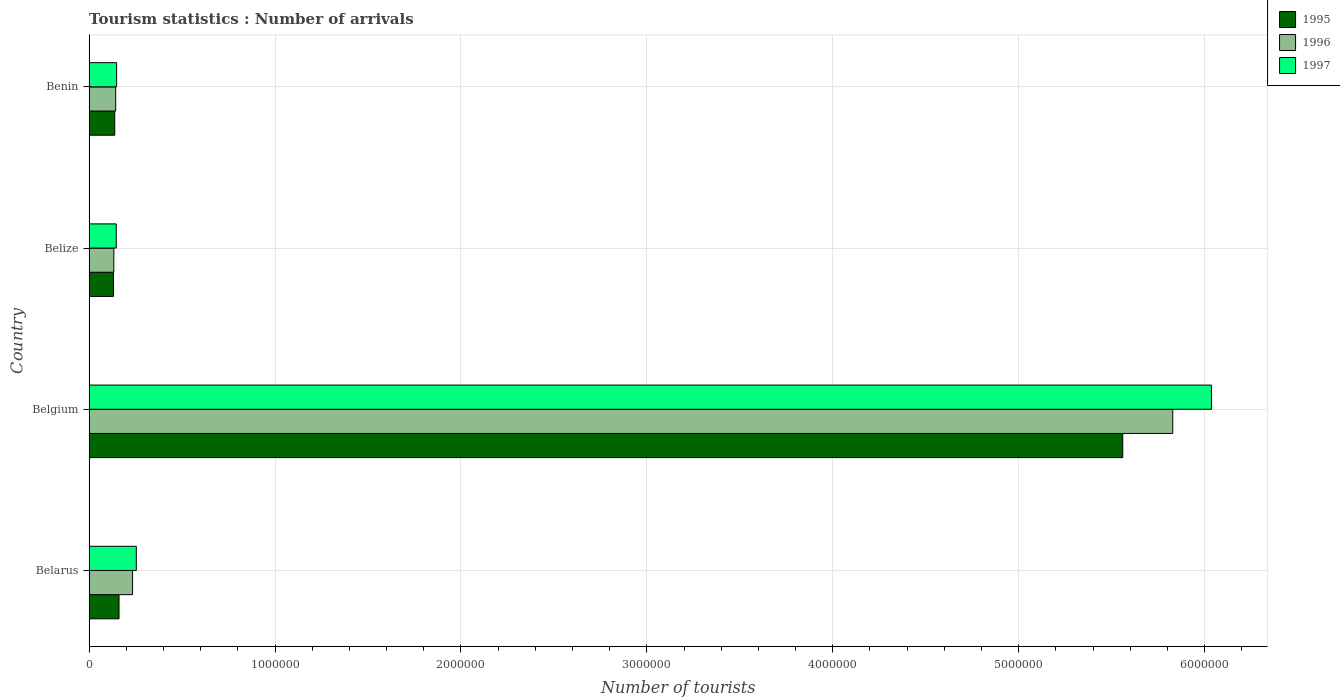Are the number of bars per tick equal to the number of legend labels?
Ensure brevity in your answer.  Yes. Are the number of bars on each tick of the Y-axis equal?
Make the answer very short. Yes. How many bars are there on the 1st tick from the top?
Give a very brief answer. 3. How many bars are there on the 1st tick from the bottom?
Your answer should be compact. 3. What is the label of the 4th group of bars from the top?
Ensure brevity in your answer.  Belarus. In how many cases, is the number of bars for a given country not equal to the number of legend labels?
Offer a terse response. 0. What is the number of tourist arrivals in 1995 in Belize?
Your answer should be compact. 1.31e+05. Across all countries, what is the maximum number of tourist arrivals in 1996?
Your response must be concise. 5.83e+06. Across all countries, what is the minimum number of tourist arrivals in 1995?
Offer a terse response. 1.31e+05. In which country was the number of tourist arrivals in 1997 maximum?
Your answer should be compact. Belgium. In which country was the number of tourist arrivals in 1996 minimum?
Offer a very short reply. Belize. What is the total number of tourist arrivals in 1997 in the graph?
Ensure brevity in your answer.  6.58e+06. What is the difference between the number of tourist arrivals in 1995 in Belgium and that in Benin?
Ensure brevity in your answer.  5.42e+06. What is the difference between the number of tourist arrivals in 1995 in Belarus and the number of tourist arrivals in 1996 in Benin?
Make the answer very short. 1.80e+04. What is the average number of tourist arrivals in 1995 per country?
Keep it short and to the point. 1.50e+06. What is the difference between the number of tourist arrivals in 1995 and number of tourist arrivals in 1997 in Belarus?
Keep it short and to the point. -9.30e+04. In how many countries, is the number of tourist arrivals in 1997 greater than 3600000 ?
Provide a short and direct response. 1. What is the ratio of the number of tourist arrivals in 1995 in Belgium to that in Belize?
Make the answer very short. 42.44. Is the difference between the number of tourist arrivals in 1995 in Belgium and Belize greater than the difference between the number of tourist arrivals in 1997 in Belgium and Belize?
Keep it short and to the point. No. What is the difference between the highest and the second highest number of tourist arrivals in 1995?
Provide a short and direct response. 5.40e+06. What is the difference between the highest and the lowest number of tourist arrivals in 1995?
Make the answer very short. 5.43e+06. In how many countries, is the number of tourist arrivals in 1997 greater than the average number of tourist arrivals in 1997 taken over all countries?
Offer a terse response. 1. What does the 2nd bar from the top in Belize represents?
Give a very brief answer. 1996. What does the 3rd bar from the bottom in Belgium represents?
Your answer should be compact. 1997. How many countries are there in the graph?
Offer a terse response. 4. Are the values on the major ticks of X-axis written in scientific E-notation?
Your answer should be compact. No. Where does the legend appear in the graph?
Ensure brevity in your answer.  Top right. What is the title of the graph?
Give a very brief answer. Tourism statistics : Number of arrivals. Does "1997" appear as one of the legend labels in the graph?
Make the answer very short. Yes. What is the label or title of the X-axis?
Your response must be concise. Number of tourists. What is the label or title of the Y-axis?
Your answer should be very brief. Country. What is the Number of tourists in 1995 in Belarus?
Make the answer very short. 1.61e+05. What is the Number of tourists of 1996 in Belarus?
Your answer should be compact. 2.34e+05. What is the Number of tourists in 1997 in Belarus?
Ensure brevity in your answer.  2.54e+05. What is the Number of tourists in 1995 in Belgium?
Ensure brevity in your answer.  5.56e+06. What is the Number of tourists in 1996 in Belgium?
Provide a succinct answer. 5.83e+06. What is the Number of tourists of 1997 in Belgium?
Ensure brevity in your answer.  6.04e+06. What is the Number of tourists in 1995 in Belize?
Provide a short and direct response. 1.31e+05. What is the Number of tourists in 1996 in Belize?
Provide a succinct answer. 1.33e+05. What is the Number of tourists in 1997 in Belize?
Offer a terse response. 1.46e+05. What is the Number of tourists in 1995 in Benin?
Keep it short and to the point. 1.38e+05. What is the Number of tourists of 1996 in Benin?
Give a very brief answer. 1.43e+05. What is the Number of tourists in 1997 in Benin?
Your response must be concise. 1.48e+05. Across all countries, what is the maximum Number of tourists of 1995?
Provide a short and direct response. 5.56e+06. Across all countries, what is the maximum Number of tourists in 1996?
Provide a short and direct response. 5.83e+06. Across all countries, what is the maximum Number of tourists in 1997?
Keep it short and to the point. 6.04e+06. Across all countries, what is the minimum Number of tourists in 1995?
Offer a terse response. 1.31e+05. Across all countries, what is the minimum Number of tourists of 1996?
Keep it short and to the point. 1.33e+05. Across all countries, what is the minimum Number of tourists in 1997?
Your answer should be very brief. 1.46e+05. What is the total Number of tourists in 1995 in the graph?
Your answer should be compact. 5.99e+06. What is the total Number of tourists of 1996 in the graph?
Provide a succinct answer. 6.34e+06. What is the total Number of tourists in 1997 in the graph?
Offer a terse response. 6.58e+06. What is the difference between the Number of tourists of 1995 in Belarus and that in Belgium?
Provide a succinct answer. -5.40e+06. What is the difference between the Number of tourists in 1996 in Belarus and that in Belgium?
Give a very brief answer. -5.60e+06. What is the difference between the Number of tourists in 1997 in Belarus and that in Belgium?
Give a very brief answer. -5.78e+06. What is the difference between the Number of tourists in 1996 in Belarus and that in Belize?
Your answer should be very brief. 1.01e+05. What is the difference between the Number of tourists in 1997 in Belarus and that in Belize?
Offer a very short reply. 1.08e+05. What is the difference between the Number of tourists in 1995 in Belarus and that in Benin?
Your answer should be very brief. 2.30e+04. What is the difference between the Number of tourists in 1996 in Belarus and that in Benin?
Provide a succinct answer. 9.10e+04. What is the difference between the Number of tourists in 1997 in Belarus and that in Benin?
Your response must be concise. 1.06e+05. What is the difference between the Number of tourists in 1995 in Belgium and that in Belize?
Offer a terse response. 5.43e+06. What is the difference between the Number of tourists of 1996 in Belgium and that in Belize?
Provide a succinct answer. 5.70e+06. What is the difference between the Number of tourists in 1997 in Belgium and that in Belize?
Give a very brief answer. 5.89e+06. What is the difference between the Number of tourists in 1995 in Belgium and that in Benin?
Offer a very short reply. 5.42e+06. What is the difference between the Number of tourists in 1996 in Belgium and that in Benin?
Provide a succinct answer. 5.69e+06. What is the difference between the Number of tourists in 1997 in Belgium and that in Benin?
Give a very brief answer. 5.89e+06. What is the difference between the Number of tourists of 1995 in Belize and that in Benin?
Your answer should be very brief. -7000. What is the difference between the Number of tourists of 1997 in Belize and that in Benin?
Your response must be concise. -2000. What is the difference between the Number of tourists in 1995 in Belarus and the Number of tourists in 1996 in Belgium?
Provide a succinct answer. -5.67e+06. What is the difference between the Number of tourists of 1995 in Belarus and the Number of tourists of 1997 in Belgium?
Make the answer very short. -5.88e+06. What is the difference between the Number of tourists in 1996 in Belarus and the Number of tourists in 1997 in Belgium?
Ensure brevity in your answer.  -5.80e+06. What is the difference between the Number of tourists in 1995 in Belarus and the Number of tourists in 1996 in Belize?
Make the answer very short. 2.80e+04. What is the difference between the Number of tourists of 1995 in Belarus and the Number of tourists of 1997 in Belize?
Offer a terse response. 1.50e+04. What is the difference between the Number of tourists in 1996 in Belarus and the Number of tourists in 1997 in Belize?
Offer a terse response. 8.80e+04. What is the difference between the Number of tourists of 1995 in Belarus and the Number of tourists of 1996 in Benin?
Your answer should be very brief. 1.80e+04. What is the difference between the Number of tourists in 1995 in Belarus and the Number of tourists in 1997 in Benin?
Provide a succinct answer. 1.30e+04. What is the difference between the Number of tourists of 1996 in Belarus and the Number of tourists of 1997 in Benin?
Your response must be concise. 8.60e+04. What is the difference between the Number of tourists in 1995 in Belgium and the Number of tourists in 1996 in Belize?
Your answer should be compact. 5.43e+06. What is the difference between the Number of tourists of 1995 in Belgium and the Number of tourists of 1997 in Belize?
Give a very brief answer. 5.41e+06. What is the difference between the Number of tourists in 1996 in Belgium and the Number of tourists in 1997 in Belize?
Ensure brevity in your answer.  5.68e+06. What is the difference between the Number of tourists in 1995 in Belgium and the Number of tourists in 1996 in Benin?
Your answer should be very brief. 5.42e+06. What is the difference between the Number of tourists in 1995 in Belgium and the Number of tourists in 1997 in Benin?
Your response must be concise. 5.41e+06. What is the difference between the Number of tourists of 1996 in Belgium and the Number of tourists of 1997 in Benin?
Make the answer very short. 5.68e+06. What is the difference between the Number of tourists of 1995 in Belize and the Number of tourists of 1996 in Benin?
Your answer should be compact. -1.20e+04. What is the difference between the Number of tourists in 1995 in Belize and the Number of tourists in 1997 in Benin?
Your answer should be very brief. -1.70e+04. What is the difference between the Number of tourists in 1996 in Belize and the Number of tourists in 1997 in Benin?
Offer a very short reply. -1.50e+04. What is the average Number of tourists in 1995 per country?
Provide a short and direct response. 1.50e+06. What is the average Number of tourists in 1996 per country?
Make the answer very short. 1.58e+06. What is the average Number of tourists of 1997 per country?
Your response must be concise. 1.65e+06. What is the difference between the Number of tourists in 1995 and Number of tourists in 1996 in Belarus?
Offer a terse response. -7.30e+04. What is the difference between the Number of tourists in 1995 and Number of tourists in 1997 in Belarus?
Your response must be concise. -9.30e+04. What is the difference between the Number of tourists of 1996 and Number of tourists of 1997 in Belarus?
Give a very brief answer. -2.00e+04. What is the difference between the Number of tourists in 1995 and Number of tourists in 1996 in Belgium?
Offer a terse response. -2.69e+05. What is the difference between the Number of tourists in 1995 and Number of tourists in 1997 in Belgium?
Make the answer very short. -4.77e+05. What is the difference between the Number of tourists in 1996 and Number of tourists in 1997 in Belgium?
Give a very brief answer. -2.08e+05. What is the difference between the Number of tourists in 1995 and Number of tourists in 1996 in Belize?
Offer a terse response. -2000. What is the difference between the Number of tourists in 1995 and Number of tourists in 1997 in Belize?
Your response must be concise. -1.50e+04. What is the difference between the Number of tourists of 1996 and Number of tourists of 1997 in Belize?
Give a very brief answer. -1.30e+04. What is the difference between the Number of tourists of 1995 and Number of tourists of 1996 in Benin?
Offer a very short reply. -5000. What is the difference between the Number of tourists of 1996 and Number of tourists of 1997 in Benin?
Offer a very short reply. -5000. What is the ratio of the Number of tourists in 1995 in Belarus to that in Belgium?
Your response must be concise. 0.03. What is the ratio of the Number of tourists of 1996 in Belarus to that in Belgium?
Ensure brevity in your answer.  0.04. What is the ratio of the Number of tourists in 1997 in Belarus to that in Belgium?
Provide a short and direct response. 0.04. What is the ratio of the Number of tourists of 1995 in Belarus to that in Belize?
Make the answer very short. 1.23. What is the ratio of the Number of tourists of 1996 in Belarus to that in Belize?
Keep it short and to the point. 1.76. What is the ratio of the Number of tourists of 1997 in Belarus to that in Belize?
Make the answer very short. 1.74. What is the ratio of the Number of tourists in 1995 in Belarus to that in Benin?
Provide a succinct answer. 1.17. What is the ratio of the Number of tourists of 1996 in Belarus to that in Benin?
Offer a terse response. 1.64. What is the ratio of the Number of tourists of 1997 in Belarus to that in Benin?
Give a very brief answer. 1.72. What is the ratio of the Number of tourists in 1995 in Belgium to that in Belize?
Keep it short and to the point. 42.44. What is the ratio of the Number of tourists in 1996 in Belgium to that in Belize?
Keep it short and to the point. 43.83. What is the ratio of the Number of tourists of 1997 in Belgium to that in Belize?
Ensure brevity in your answer.  41.35. What is the ratio of the Number of tourists of 1995 in Belgium to that in Benin?
Your answer should be compact. 40.29. What is the ratio of the Number of tourists in 1996 in Belgium to that in Benin?
Your response must be concise. 40.76. What is the ratio of the Number of tourists of 1997 in Belgium to that in Benin?
Offer a very short reply. 40.79. What is the ratio of the Number of tourists of 1995 in Belize to that in Benin?
Provide a succinct answer. 0.95. What is the ratio of the Number of tourists in 1996 in Belize to that in Benin?
Your response must be concise. 0.93. What is the ratio of the Number of tourists in 1997 in Belize to that in Benin?
Ensure brevity in your answer.  0.99. What is the difference between the highest and the second highest Number of tourists in 1995?
Provide a short and direct response. 5.40e+06. What is the difference between the highest and the second highest Number of tourists of 1996?
Make the answer very short. 5.60e+06. What is the difference between the highest and the second highest Number of tourists of 1997?
Your answer should be compact. 5.78e+06. What is the difference between the highest and the lowest Number of tourists in 1995?
Your response must be concise. 5.43e+06. What is the difference between the highest and the lowest Number of tourists in 1996?
Your answer should be very brief. 5.70e+06. What is the difference between the highest and the lowest Number of tourists of 1997?
Ensure brevity in your answer.  5.89e+06. 